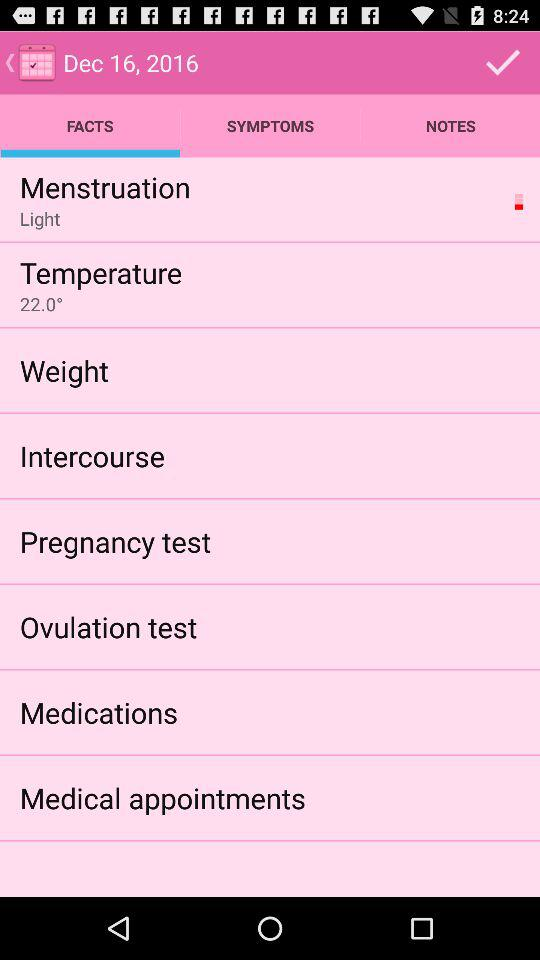What is the temperature? The temperature is 22°. 